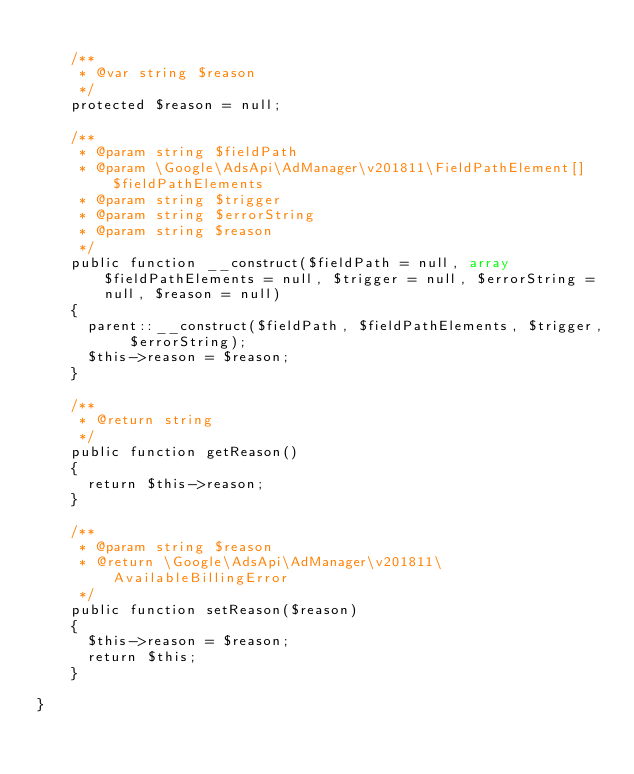Convert code to text. <code><loc_0><loc_0><loc_500><loc_500><_PHP_>
    /**
     * @var string $reason
     */
    protected $reason = null;

    /**
     * @param string $fieldPath
     * @param \Google\AdsApi\AdManager\v201811\FieldPathElement[] $fieldPathElements
     * @param string $trigger
     * @param string $errorString
     * @param string $reason
     */
    public function __construct($fieldPath = null, array $fieldPathElements = null, $trigger = null, $errorString = null, $reason = null)
    {
      parent::__construct($fieldPath, $fieldPathElements, $trigger, $errorString);
      $this->reason = $reason;
    }

    /**
     * @return string
     */
    public function getReason()
    {
      return $this->reason;
    }

    /**
     * @param string $reason
     * @return \Google\AdsApi\AdManager\v201811\AvailableBillingError
     */
    public function setReason($reason)
    {
      $this->reason = $reason;
      return $this;
    }

}
</code> 